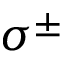<formula> <loc_0><loc_0><loc_500><loc_500>\sigma ^ { \pm }</formula> 